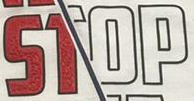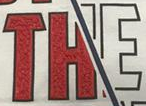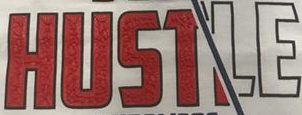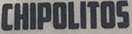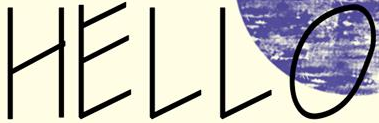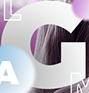Transcribe the words shown in these images in order, separated by a semicolon. STOP; THE; HUSTLE; CHIPOLITOS; HELLO; G 